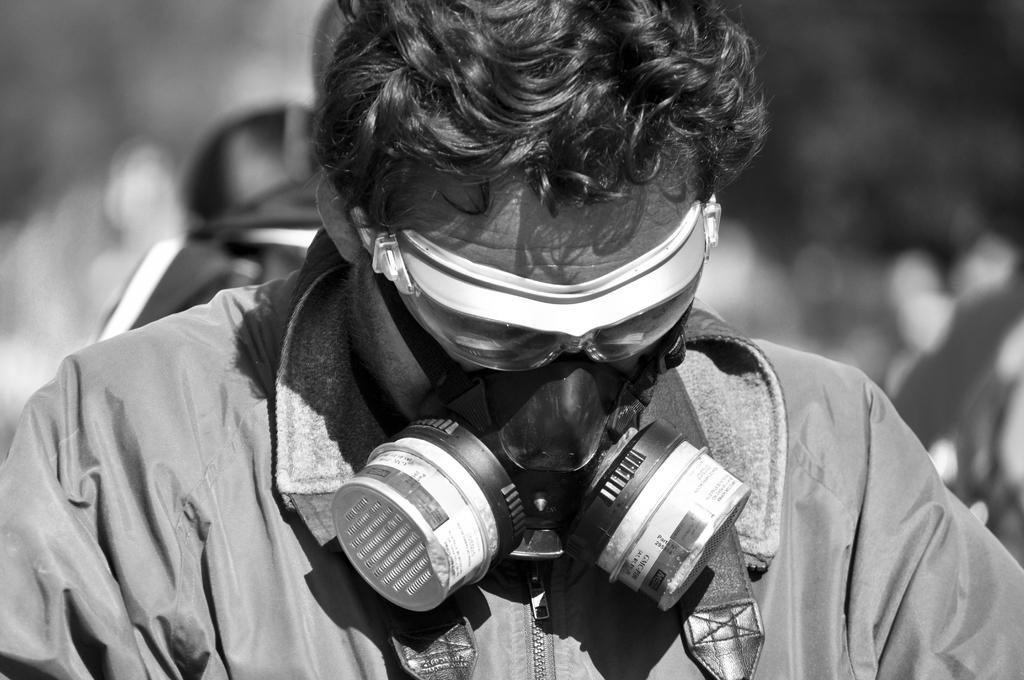What is the color scheme of the image? The image is black and white. Can you describe the person in the image? The person is wearing a jacket and a face mask. What is the background of the image like? The background of the image is blurred. What type of insect can be seen crawling on the person's face mask in the image? There are no insects visible in the image, as it is a black and white image of a person wearing a jacket and a face mask with a blurred background. 